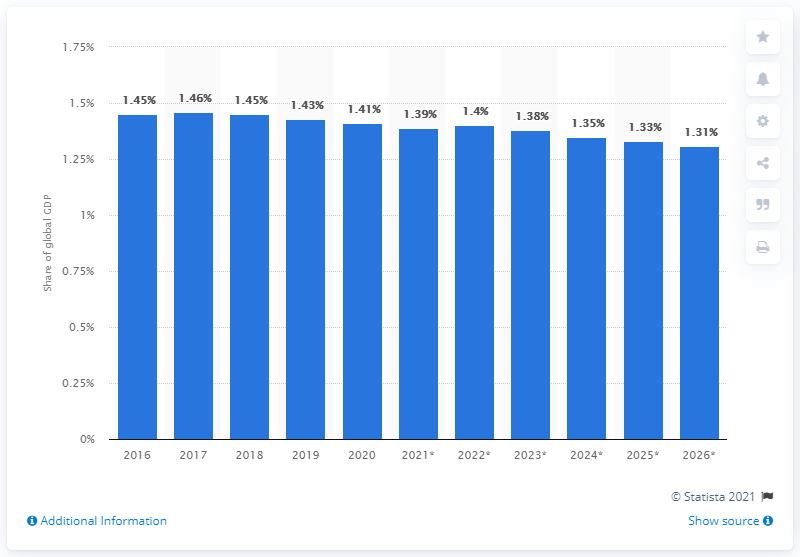Outline some significant characteristics in this image. Canada's share of the global GDP in 2020 was 1.4%. 